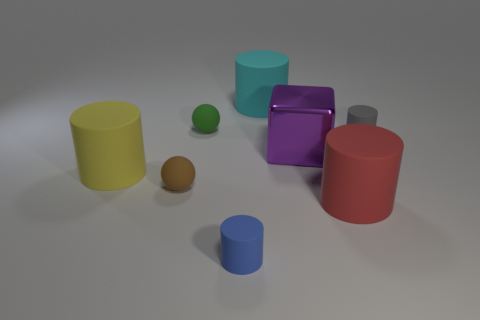Subtract 1 cylinders. How many cylinders are left? 4 Subtract all purple cylinders. Subtract all yellow balls. How many cylinders are left? 5 Add 2 red rubber balls. How many objects exist? 10 Subtract all blocks. How many objects are left? 7 Add 3 tiny rubber balls. How many tiny rubber balls exist? 5 Subtract 0 cyan cubes. How many objects are left? 8 Subtract all tiny gray cylinders. Subtract all small green rubber balls. How many objects are left? 6 Add 5 large cyan matte objects. How many large cyan matte objects are left? 6 